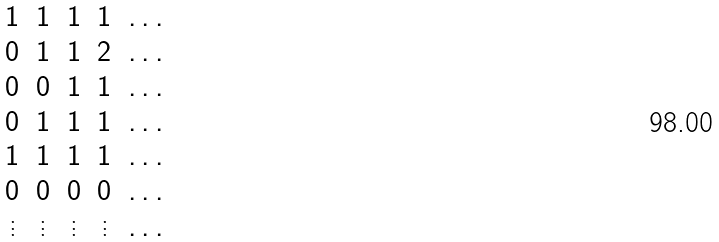Convert formula to latex. <formula><loc_0><loc_0><loc_500><loc_500>\begin{matrix} 1 & 1 & 1 & 1 & \dots \\ 0 & 1 & 1 & 2 & \dots \\ 0 & 0 & 1 & 1 & \dots \\ 0 & 1 & 1 & 1 & \dots \\ 1 & 1 & 1 & 1 & \dots \\ 0 & 0 & 0 & 0 & \dots \\ \vdots & \vdots & \vdots & \vdots & \dots \end{matrix}</formula> 